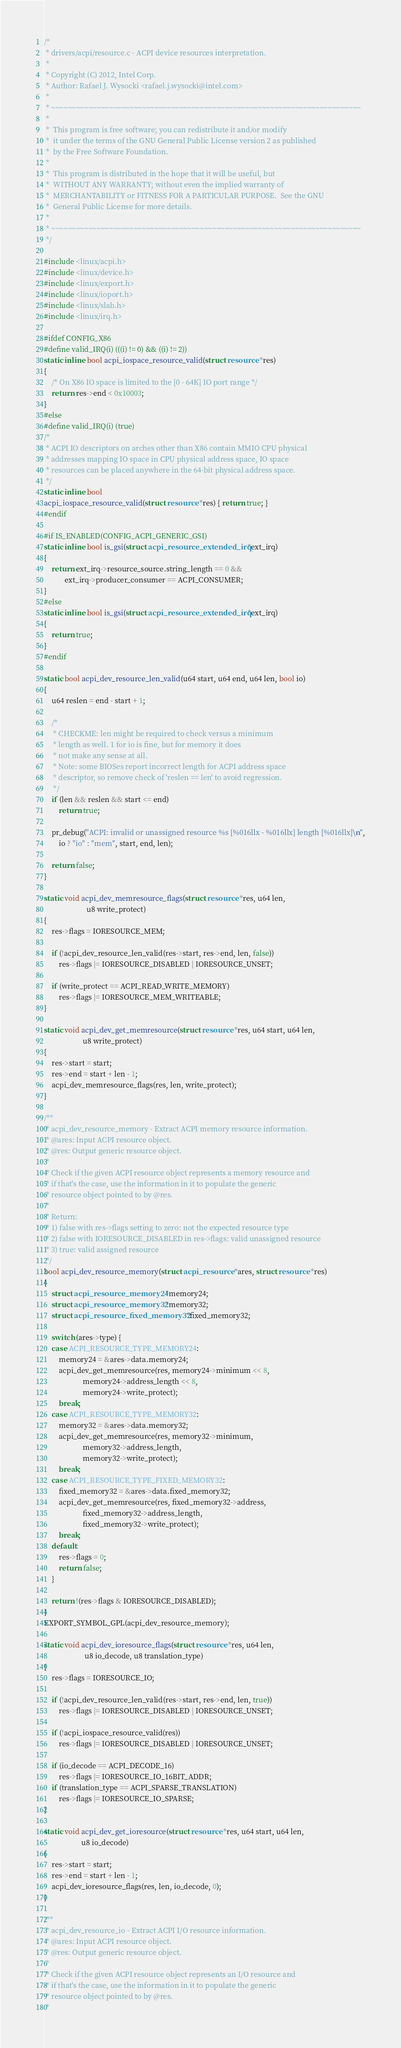Convert code to text. <code><loc_0><loc_0><loc_500><loc_500><_C_>/*
 * drivers/acpi/resource.c - ACPI device resources interpretation.
 *
 * Copyright (C) 2012, Intel Corp.
 * Author: Rafael J. Wysocki <rafael.j.wysocki@intel.com>
 *
 * ~~~~~~~~~~~~~~~~~~~~~~~~~~~~~~~~~~~~~~~~~~~~~~~~~~~~~~~~~~~~~~~~~~~~~~~~~~~
 *
 *  This program is free software; you can redistribute it and/or modify
 *  it under the terms of the GNU General Public License version 2 as published
 *  by the Free Software Foundation.
 *
 *  This program is distributed in the hope that it will be useful, but
 *  WITHOUT ANY WARRANTY; without even the implied warranty of
 *  MERCHANTABILITY or FITNESS FOR A PARTICULAR PURPOSE.  See the GNU
 *  General Public License for more details.
 *
 * ~~~~~~~~~~~~~~~~~~~~~~~~~~~~~~~~~~~~~~~~~~~~~~~~~~~~~~~~~~~~~~~~~~~~~~~~~~~
 */

#include <linux/acpi.h>
#include <linux/device.h>
#include <linux/export.h>
#include <linux/ioport.h>
#include <linux/slab.h>
#include <linux/irq.h>

#ifdef CONFIG_X86
#define valid_IRQ(i) (((i) != 0) && ((i) != 2))
static inline bool acpi_iospace_resource_valid(struct resource *res)
{
	/* On X86 IO space is limited to the [0 - 64K] IO port range */
	return res->end < 0x10003;
}
#else
#define valid_IRQ(i) (true)
/*
 * ACPI IO descriptors on arches other than X86 contain MMIO CPU physical
 * addresses mapping IO space in CPU physical address space, IO space
 * resources can be placed anywhere in the 64-bit physical address space.
 */
static inline bool
acpi_iospace_resource_valid(struct resource *res) { return true; }
#endif

#if IS_ENABLED(CONFIG_ACPI_GENERIC_GSI)
static inline bool is_gsi(struct acpi_resource_extended_irq *ext_irq)
{
	return ext_irq->resource_source.string_length == 0 &&
	       ext_irq->producer_consumer == ACPI_CONSUMER;
}
#else
static inline bool is_gsi(struct acpi_resource_extended_irq *ext_irq)
{
	return true;
}
#endif

static bool acpi_dev_resource_len_valid(u64 start, u64 end, u64 len, bool io)
{
	u64 reslen = end - start + 1;

	/*
	 * CHECKME: len might be required to check versus a minimum
	 * length as well. 1 for io is fine, but for memory it does
	 * not make any sense at all.
	 * Note: some BIOSes report incorrect length for ACPI address space
	 * descriptor, so remove check of 'reslen == len' to avoid regression.
	 */
	if (len && reslen && start <= end)
		return true;

	pr_debug("ACPI: invalid or unassigned resource %s [%016llx - %016llx] length [%016llx]\n",
		io ? "io" : "mem", start, end, len);

	return false;
}

static void acpi_dev_memresource_flags(struct resource *res, u64 len,
				       u8 write_protect)
{
	res->flags = IORESOURCE_MEM;

	if (!acpi_dev_resource_len_valid(res->start, res->end, len, false))
		res->flags |= IORESOURCE_DISABLED | IORESOURCE_UNSET;

	if (write_protect == ACPI_READ_WRITE_MEMORY)
		res->flags |= IORESOURCE_MEM_WRITEABLE;
}

static void acpi_dev_get_memresource(struct resource *res, u64 start, u64 len,
				     u8 write_protect)
{
	res->start = start;
	res->end = start + len - 1;
	acpi_dev_memresource_flags(res, len, write_protect);
}

/**
 * acpi_dev_resource_memory - Extract ACPI memory resource information.
 * @ares: Input ACPI resource object.
 * @res: Output generic resource object.
 *
 * Check if the given ACPI resource object represents a memory resource and
 * if that's the case, use the information in it to populate the generic
 * resource object pointed to by @res.
 *
 * Return:
 * 1) false with res->flags setting to zero: not the expected resource type
 * 2) false with IORESOURCE_DISABLED in res->flags: valid unassigned resource
 * 3) true: valid assigned resource
 */
bool acpi_dev_resource_memory(struct acpi_resource *ares, struct resource *res)
{
	struct acpi_resource_memory24 *memory24;
	struct acpi_resource_memory32 *memory32;
	struct acpi_resource_fixed_memory32 *fixed_memory32;

	switch (ares->type) {
	case ACPI_RESOURCE_TYPE_MEMORY24:
		memory24 = &ares->data.memory24;
		acpi_dev_get_memresource(res, memory24->minimum << 8,
					 memory24->address_length << 8,
					 memory24->write_protect);
		break;
	case ACPI_RESOURCE_TYPE_MEMORY32:
		memory32 = &ares->data.memory32;
		acpi_dev_get_memresource(res, memory32->minimum,
					 memory32->address_length,
					 memory32->write_protect);
		break;
	case ACPI_RESOURCE_TYPE_FIXED_MEMORY32:
		fixed_memory32 = &ares->data.fixed_memory32;
		acpi_dev_get_memresource(res, fixed_memory32->address,
					 fixed_memory32->address_length,
					 fixed_memory32->write_protect);
		break;
	default:
		res->flags = 0;
		return false;
	}

	return !(res->flags & IORESOURCE_DISABLED);
}
EXPORT_SYMBOL_GPL(acpi_dev_resource_memory);

static void acpi_dev_ioresource_flags(struct resource *res, u64 len,
				      u8 io_decode, u8 translation_type)
{
	res->flags = IORESOURCE_IO;

	if (!acpi_dev_resource_len_valid(res->start, res->end, len, true))
		res->flags |= IORESOURCE_DISABLED | IORESOURCE_UNSET;

	if (!acpi_iospace_resource_valid(res))
		res->flags |= IORESOURCE_DISABLED | IORESOURCE_UNSET;

	if (io_decode == ACPI_DECODE_16)
		res->flags |= IORESOURCE_IO_16BIT_ADDR;
	if (translation_type == ACPI_SPARSE_TRANSLATION)
		res->flags |= IORESOURCE_IO_SPARSE;
}

static void acpi_dev_get_ioresource(struct resource *res, u64 start, u64 len,
				    u8 io_decode)
{
	res->start = start;
	res->end = start + len - 1;
	acpi_dev_ioresource_flags(res, len, io_decode, 0);
}

/**
 * acpi_dev_resource_io - Extract ACPI I/O resource information.
 * @ares: Input ACPI resource object.
 * @res: Output generic resource object.
 *
 * Check if the given ACPI resource object represents an I/O resource and
 * if that's the case, use the information in it to populate the generic
 * resource object pointed to by @res.
 *</code> 